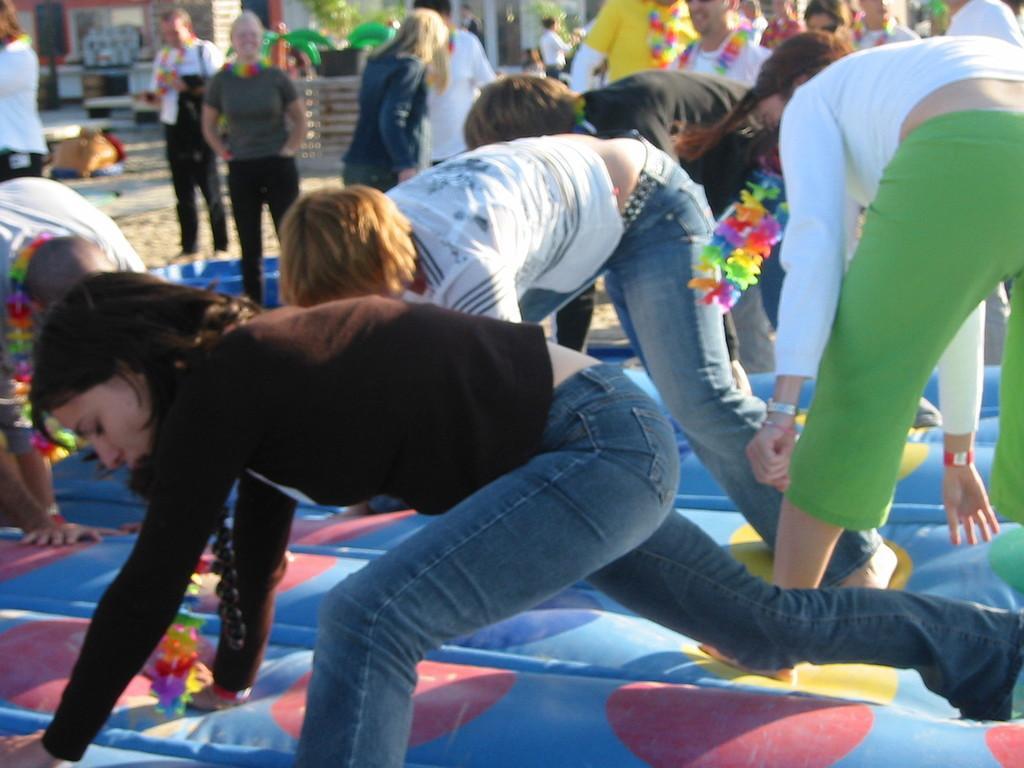Please provide a concise description of this image. In this image there are a few people bending forward. There is a mat on the ground. Behind them there are a few people standing. Behind them there is a railing. In the background there are stalls. 